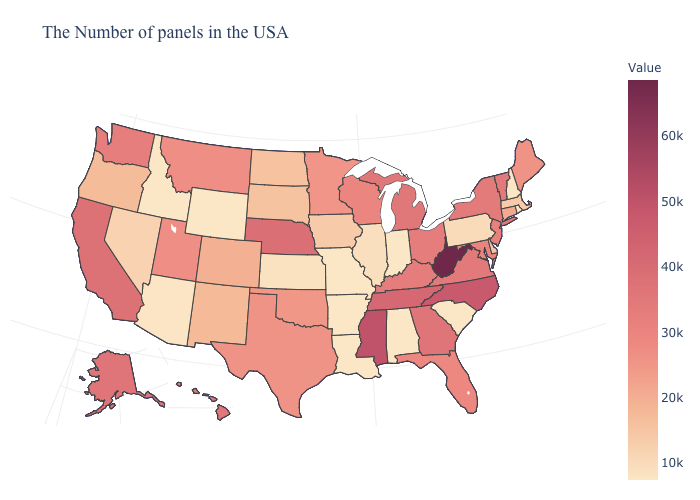Which states have the highest value in the USA?
Answer briefly. West Virginia. Which states have the lowest value in the USA?
Short answer required. Rhode Island, New Hampshire, South Carolina, Indiana, Alabama, Louisiana, Missouri, Arkansas, Wyoming, Idaho. Does Kansas have a higher value than Maine?
Concise answer only. No. Which states have the lowest value in the USA?
Answer briefly. Rhode Island, New Hampshire, South Carolina, Indiana, Alabama, Louisiana, Missouri, Arkansas, Wyoming, Idaho. Does California have the highest value in the West?
Short answer required. Yes. Does Nevada have the highest value in the USA?
Concise answer only. No. 